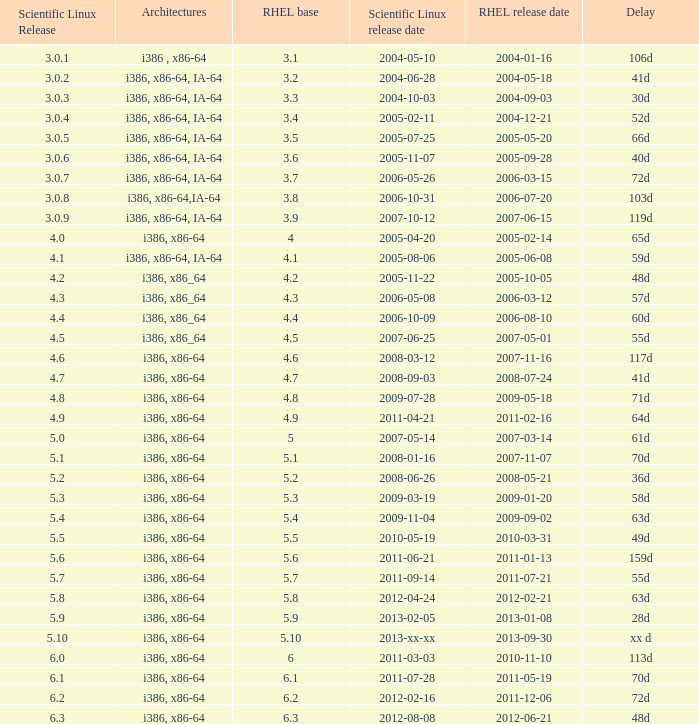Name the delay when scientific linux release is 5.10 Xx d. 